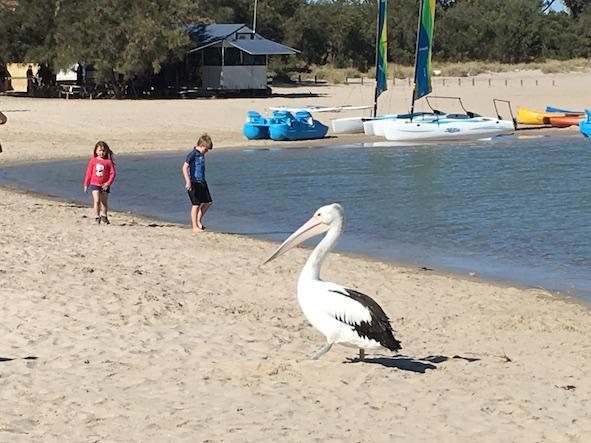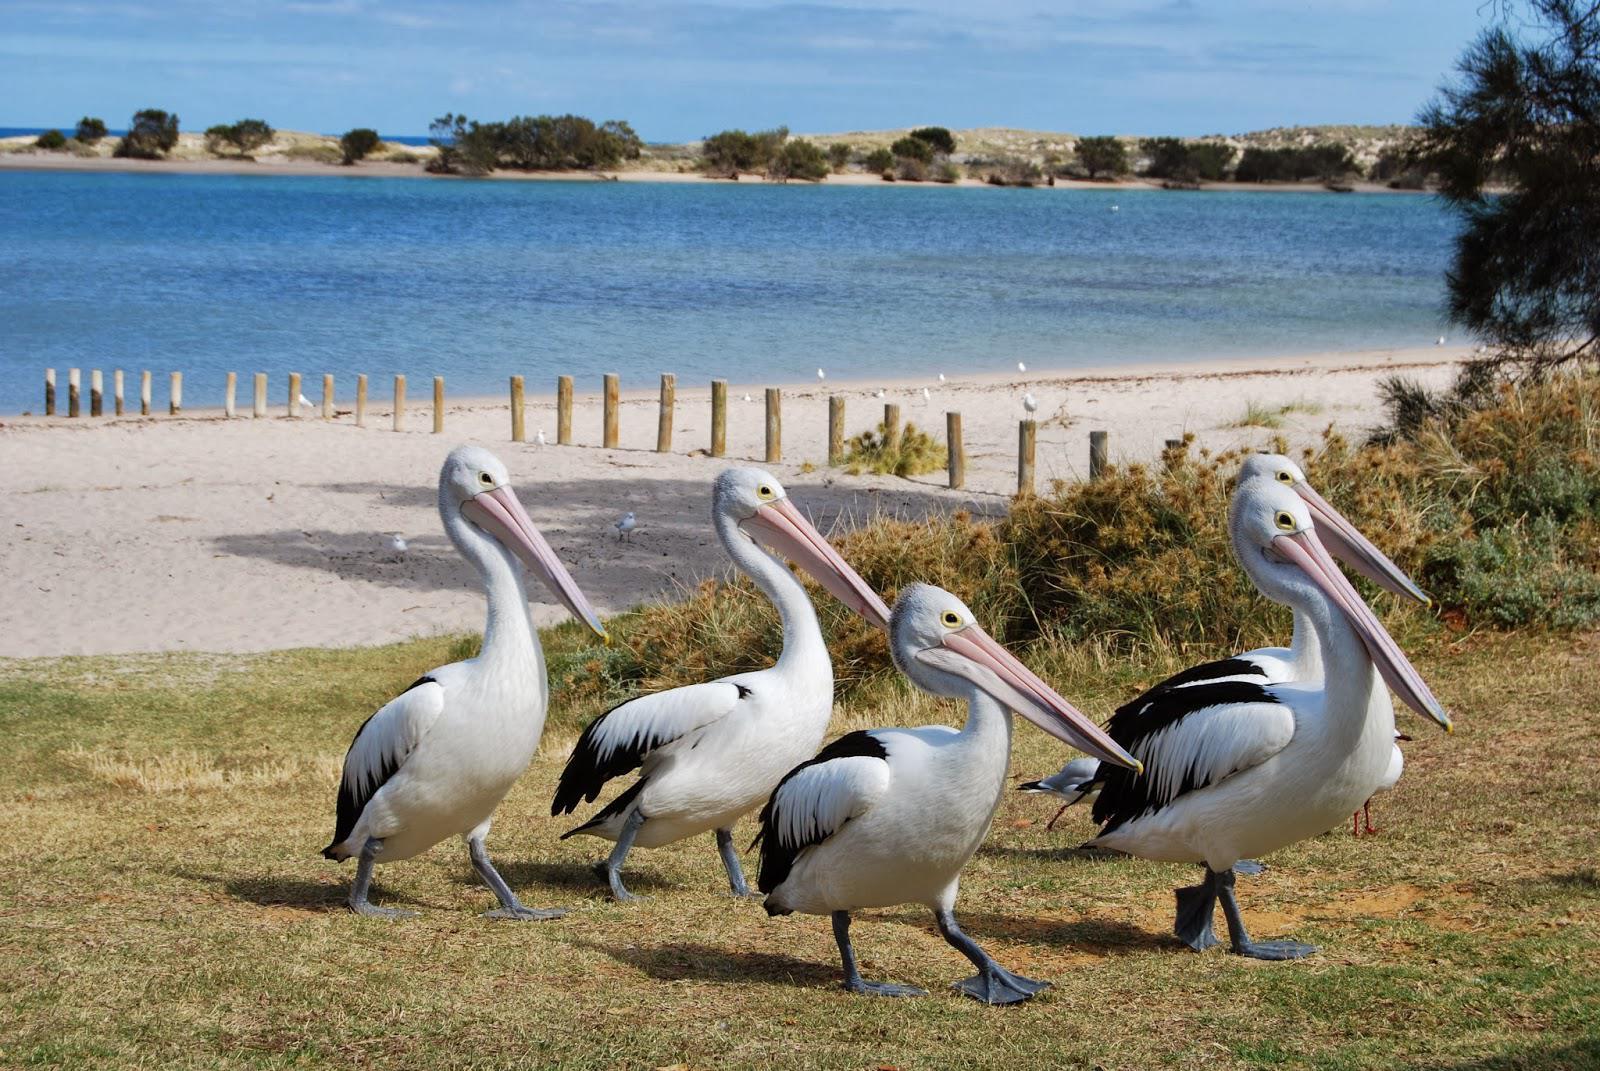The first image is the image on the left, the second image is the image on the right. Assess this claim about the two images: "There is no more than one bird on a beach in the left image.". Correct or not? Answer yes or no. Yes. The first image is the image on the left, the second image is the image on the right. Evaluate the accuracy of this statement regarding the images: "There is a single human feeding a pelican with white and black feathers.". Is it true? Answer yes or no. No. 